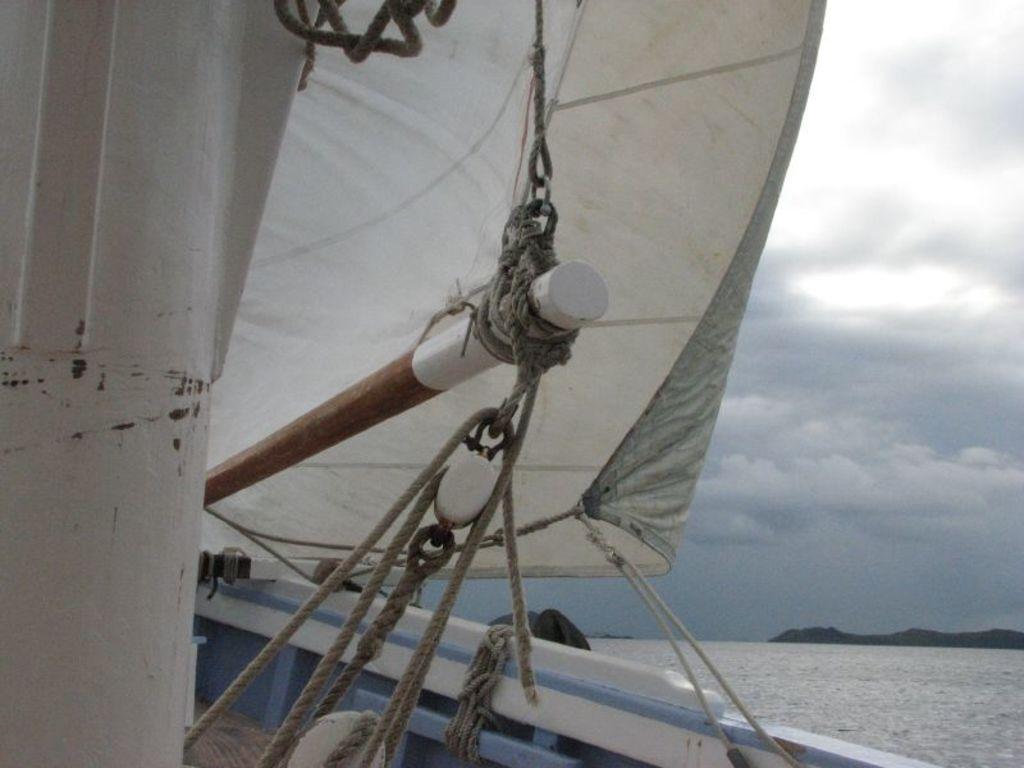Can you describe this image briefly? In this image on the left, there is a boat, cables, cloth. On the right there are hills, water, sky and clouds. 